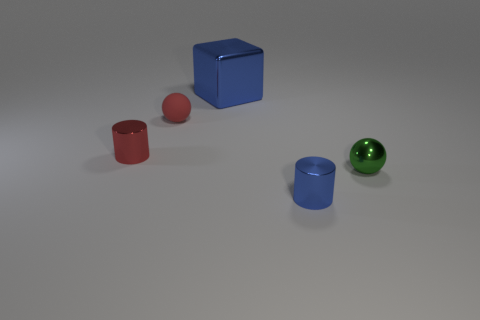Is there any other thing that has the same size as the cube?
Your answer should be compact. No. What number of small shiny cylinders are the same color as the big metallic thing?
Your answer should be compact. 1. There is a small shiny object that is left of the small red matte ball; is there a green sphere that is behind it?
Offer a terse response. No. Is the color of the metallic thing that is behind the tiny matte thing the same as the cylinder that is in front of the tiny red metal thing?
Provide a succinct answer. Yes. There is another ball that is the same size as the metal sphere; what color is it?
Your response must be concise. Red. Are there the same number of small rubber things in front of the tiny red ball and tiny metallic cylinders that are on the right side of the big blue shiny thing?
Keep it short and to the point. No. There is a cylinder that is behind the tiny object to the right of the blue metal cylinder; what is it made of?
Keep it short and to the point. Metal. How many objects are large blue shiny blocks or large purple shiny blocks?
Keep it short and to the point. 1. There is a cylinder that is the same color as the large block; what size is it?
Ensure brevity in your answer.  Small. Is the number of green matte spheres less than the number of red matte balls?
Give a very brief answer. Yes. 